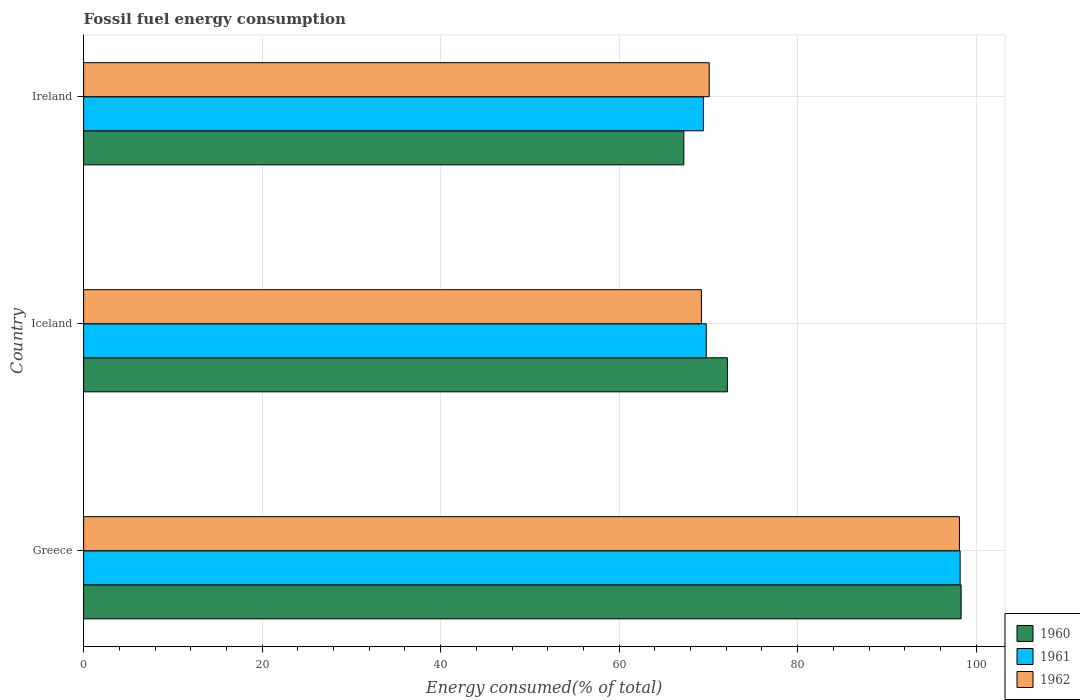How many groups of bars are there?
Offer a very short reply. 3. Are the number of bars per tick equal to the number of legend labels?
Ensure brevity in your answer.  Yes. Are the number of bars on each tick of the Y-axis equal?
Your answer should be very brief. Yes. What is the label of the 3rd group of bars from the top?
Make the answer very short. Greece. What is the percentage of energy consumed in 1962 in Greece?
Provide a short and direct response. 98.12. Across all countries, what is the maximum percentage of energy consumed in 1961?
Ensure brevity in your answer.  98.2. Across all countries, what is the minimum percentage of energy consumed in 1962?
Offer a terse response. 69.22. In which country was the percentage of energy consumed in 1961 minimum?
Ensure brevity in your answer.  Ireland. What is the total percentage of energy consumed in 1960 in the graph?
Your response must be concise. 237.68. What is the difference between the percentage of energy consumed in 1962 in Iceland and that in Ireland?
Provide a succinct answer. -0.87. What is the difference between the percentage of energy consumed in 1961 in Greece and the percentage of energy consumed in 1962 in Ireland?
Your response must be concise. 28.11. What is the average percentage of energy consumed in 1962 per country?
Provide a succinct answer. 79.14. What is the difference between the percentage of energy consumed in 1960 and percentage of energy consumed in 1961 in Ireland?
Your answer should be compact. -2.2. What is the ratio of the percentage of energy consumed in 1962 in Greece to that in Iceland?
Keep it short and to the point. 1.42. Is the difference between the percentage of energy consumed in 1960 in Iceland and Ireland greater than the difference between the percentage of energy consumed in 1961 in Iceland and Ireland?
Your answer should be very brief. Yes. What is the difference between the highest and the second highest percentage of energy consumed in 1962?
Make the answer very short. 28.04. What is the difference between the highest and the lowest percentage of energy consumed in 1961?
Give a very brief answer. 28.76. In how many countries, is the percentage of energy consumed in 1960 greater than the average percentage of energy consumed in 1960 taken over all countries?
Your response must be concise. 1. Is the sum of the percentage of energy consumed in 1960 in Greece and Ireland greater than the maximum percentage of energy consumed in 1961 across all countries?
Your answer should be very brief. Yes. What does the 1st bar from the top in Iceland represents?
Provide a succinct answer. 1962. What is the difference between two consecutive major ticks on the X-axis?
Give a very brief answer. 20. Are the values on the major ticks of X-axis written in scientific E-notation?
Offer a terse response. No. How are the legend labels stacked?
Your answer should be compact. Vertical. What is the title of the graph?
Provide a short and direct response. Fossil fuel energy consumption. What is the label or title of the X-axis?
Give a very brief answer. Energy consumed(% of total). What is the Energy consumed(% of total) in 1960 in Greece?
Provide a short and direct response. 98.31. What is the Energy consumed(% of total) of 1961 in Greece?
Ensure brevity in your answer.  98.2. What is the Energy consumed(% of total) of 1962 in Greece?
Ensure brevity in your answer.  98.12. What is the Energy consumed(% of total) of 1960 in Iceland?
Provide a succinct answer. 72.13. What is the Energy consumed(% of total) of 1961 in Iceland?
Offer a very short reply. 69.76. What is the Energy consumed(% of total) in 1962 in Iceland?
Offer a terse response. 69.22. What is the Energy consumed(% of total) of 1960 in Ireland?
Make the answer very short. 67.24. What is the Energy consumed(% of total) of 1961 in Ireland?
Your answer should be very brief. 69.44. What is the Energy consumed(% of total) in 1962 in Ireland?
Offer a very short reply. 70.09. Across all countries, what is the maximum Energy consumed(% of total) in 1960?
Your answer should be compact. 98.31. Across all countries, what is the maximum Energy consumed(% of total) of 1961?
Provide a short and direct response. 98.2. Across all countries, what is the maximum Energy consumed(% of total) in 1962?
Offer a very short reply. 98.12. Across all countries, what is the minimum Energy consumed(% of total) of 1960?
Make the answer very short. 67.24. Across all countries, what is the minimum Energy consumed(% of total) of 1961?
Ensure brevity in your answer.  69.44. Across all countries, what is the minimum Energy consumed(% of total) in 1962?
Provide a succinct answer. 69.22. What is the total Energy consumed(% of total) in 1960 in the graph?
Keep it short and to the point. 237.68. What is the total Energy consumed(% of total) of 1961 in the graph?
Keep it short and to the point. 237.4. What is the total Energy consumed(% of total) of 1962 in the graph?
Provide a short and direct response. 237.43. What is the difference between the Energy consumed(% of total) of 1960 in Greece and that in Iceland?
Provide a short and direct response. 26.18. What is the difference between the Energy consumed(% of total) of 1961 in Greece and that in Iceland?
Your answer should be very brief. 28.44. What is the difference between the Energy consumed(% of total) of 1962 in Greece and that in Iceland?
Make the answer very short. 28.91. What is the difference between the Energy consumed(% of total) in 1960 in Greece and that in Ireland?
Offer a terse response. 31.07. What is the difference between the Energy consumed(% of total) of 1961 in Greece and that in Ireland?
Give a very brief answer. 28.76. What is the difference between the Energy consumed(% of total) in 1962 in Greece and that in Ireland?
Provide a succinct answer. 28.04. What is the difference between the Energy consumed(% of total) in 1960 in Iceland and that in Ireland?
Provide a short and direct response. 4.89. What is the difference between the Energy consumed(% of total) in 1961 in Iceland and that in Ireland?
Give a very brief answer. 0.32. What is the difference between the Energy consumed(% of total) in 1962 in Iceland and that in Ireland?
Ensure brevity in your answer.  -0.87. What is the difference between the Energy consumed(% of total) of 1960 in Greece and the Energy consumed(% of total) of 1961 in Iceland?
Offer a terse response. 28.55. What is the difference between the Energy consumed(% of total) of 1960 in Greece and the Energy consumed(% of total) of 1962 in Iceland?
Make the answer very short. 29.09. What is the difference between the Energy consumed(% of total) of 1961 in Greece and the Energy consumed(% of total) of 1962 in Iceland?
Offer a very short reply. 28.98. What is the difference between the Energy consumed(% of total) in 1960 in Greece and the Energy consumed(% of total) in 1961 in Ireland?
Your answer should be compact. 28.87. What is the difference between the Energy consumed(% of total) of 1960 in Greece and the Energy consumed(% of total) of 1962 in Ireland?
Keep it short and to the point. 28.23. What is the difference between the Energy consumed(% of total) in 1961 in Greece and the Energy consumed(% of total) in 1962 in Ireland?
Provide a short and direct response. 28.11. What is the difference between the Energy consumed(% of total) in 1960 in Iceland and the Energy consumed(% of total) in 1961 in Ireland?
Offer a very short reply. 2.69. What is the difference between the Energy consumed(% of total) in 1960 in Iceland and the Energy consumed(% of total) in 1962 in Ireland?
Offer a terse response. 2.04. What is the difference between the Energy consumed(% of total) of 1961 in Iceland and the Energy consumed(% of total) of 1962 in Ireland?
Offer a terse response. -0.33. What is the average Energy consumed(% of total) of 1960 per country?
Ensure brevity in your answer.  79.23. What is the average Energy consumed(% of total) in 1961 per country?
Keep it short and to the point. 79.13. What is the average Energy consumed(% of total) of 1962 per country?
Provide a short and direct response. 79.14. What is the difference between the Energy consumed(% of total) in 1960 and Energy consumed(% of total) in 1961 in Greece?
Make the answer very short. 0.11. What is the difference between the Energy consumed(% of total) of 1960 and Energy consumed(% of total) of 1962 in Greece?
Give a very brief answer. 0.19. What is the difference between the Energy consumed(% of total) in 1961 and Energy consumed(% of total) in 1962 in Greece?
Your response must be concise. 0.07. What is the difference between the Energy consumed(% of total) in 1960 and Energy consumed(% of total) in 1961 in Iceland?
Offer a very short reply. 2.37. What is the difference between the Energy consumed(% of total) of 1960 and Energy consumed(% of total) of 1962 in Iceland?
Your answer should be compact. 2.91. What is the difference between the Energy consumed(% of total) of 1961 and Energy consumed(% of total) of 1962 in Iceland?
Make the answer very short. 0.54. What is the difference between the Energy consumed(% of total) of 1960 and Energy consumed(% of total) of 1961 in Ireland?
Your answer should be very brief. -2.2. What is the difference between the Energy consumed(% of total) of 1960 and Energy consumed(% of total) of 1962 in Ireland?
Offer a very short reply. -2.84. What is the difference between the Energy consumed(% of total) of 1961 and Energy consumed(% of total) of 1962 in Ireland?
Your answer should be compact. -0.65. What is the ratio of the Energy consumed(% of total) in 1960 in Greece to that in Iceland?
Provide a succinct answer. 1.36. What is the ratio of the Energy consumed(% of total) of 1961 in Greece to that in Iceland?
Provide a succinct answer. 1.41. What is the ratio of the Energy consumed(% of total) in 1962 in Greece to that in Iceland?
Offer a very short reply. 1.42. What is the ratio of the Energy consumed(% of total) in 1960 in Greece to that in Ireland?
Your response must be concise. 1.46. What is the ratio of the Energy consumed(% of total) in 1961 in Greece to that in Ireland?
Your response must be concise. 1.41. What is the ratio of the Energy consumed(% of total) in 1962 in Greece to that in Ireland?
Your answer should be compact. 1.4. What is the ratio of the Energy consumed(% of total) in 1960 in Iceland to that in Ireland?
Offer a very short reply. 1.07. What is the ratio of the Energy consumed(% of total) in 1962 in Iceland to that in Ireland?
Your answer should be compact. 0.99. What is the difference between the highest and the second highest Energy consumed(% of total) of 1960?
Offer a terse response. 26.18. What is the difference between the highest and the second highest Energy consumed(% of total) in 1961?
Ensure brevity in your answer.  28.44. What is the difference between the highest and the second highest Energy consumed(% of total) in 1962?
Ensure brevity in your answer.  28.04. What is the difference between the highest and the lowest Energy consumed(% of total) of 1960?
Make the answer very short. 31.07. What is the difference between the highest and the lowest Energy consumed(% of total) of 1961?
Offer a terse response. 28.76. What is the difference between the highest and the lowest Energy consumed(% of total) in 1962?
Ensure brevity in your answer.  28.91. 